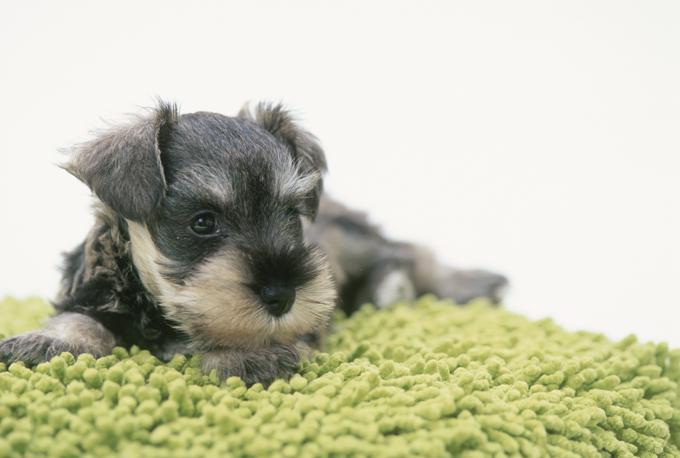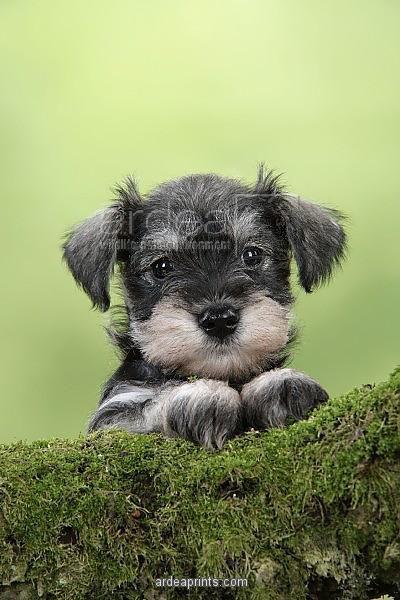The first image is the image on the left, the second image is the image on the right. For the images displayed, is the sentence "There are two dogs in one of the images." factually correct? Answer yes or no. No. 